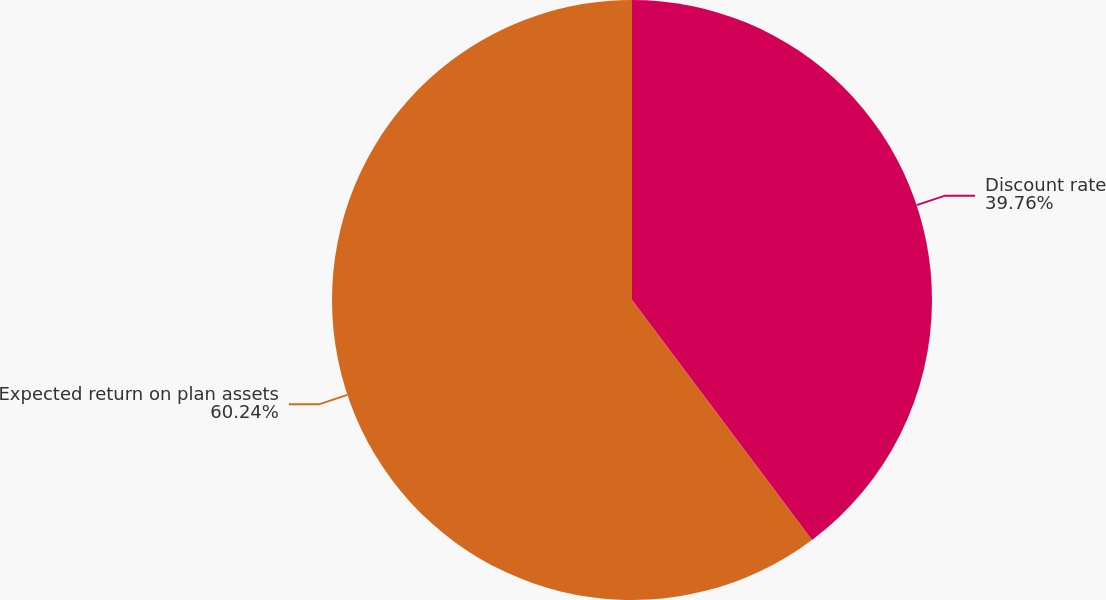Convert chart. <chart><loc_0><loc_0><loc_500><loc_500><pie_chart><fcel>Discount rate<fcel>Expected return on plan assets<nl><fcel>39.76%<fcel>60.24%<nl></chart> 